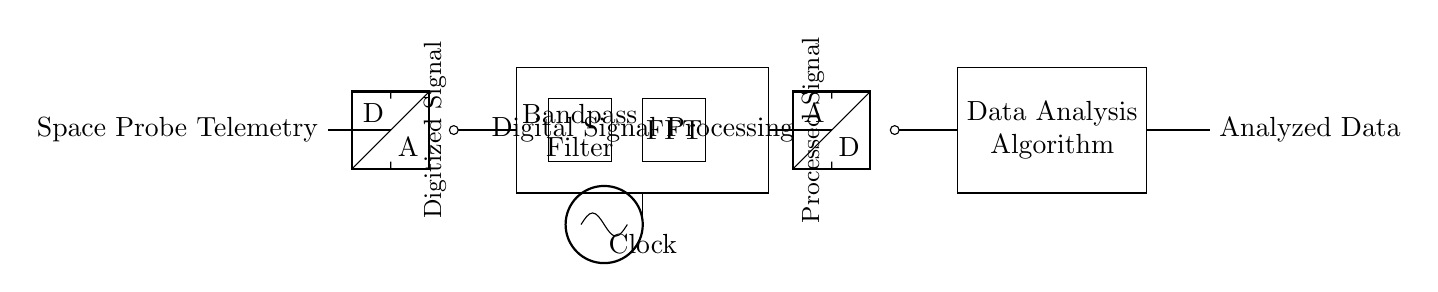What component is used to convert the analog signal to digital? The circuit includes an ADC (Analog to Digital Converter) as indicated by the symbol next to the input. This component samples the analog signal from the space probe and converts it into a digital signal for processing.
Answer: ADC What is the main function of the rectangle labeled "Digital Signal Processing"? This section represents the digital processing of the telemetries such as filtering, transforming, and analyzing the data. It encompasses the bandpass filter and FFT, which are essential for signal conditioning and analysis.
Answer: Signal processing Which filter type is utilized in this circuit? The circuit diagram explicitly identifies the bandpass filter, which allows signals within a certain frequency range to pass through while attenuating signals outside this range. This is crucial for isolating meaningful telemetry data from noise.
Answer: Bandpass filter What purpose does the FFT serve in this circuit? The FFT (Fast Fourier Transform) is used to analyze the frequency components of the digital signal. It processes the signal to determine its frequency content, enabling better understanding and interpretation of the telemetry data.
Answer: Frequency analysis How is the output signal transformed back into analog? The DAC (Digital to Analog Converter) converts the processed digital signal back into analog form for potential output or further transmission. This allows the analyzed information to be used in analog systems following processing.
Answer: DAC 